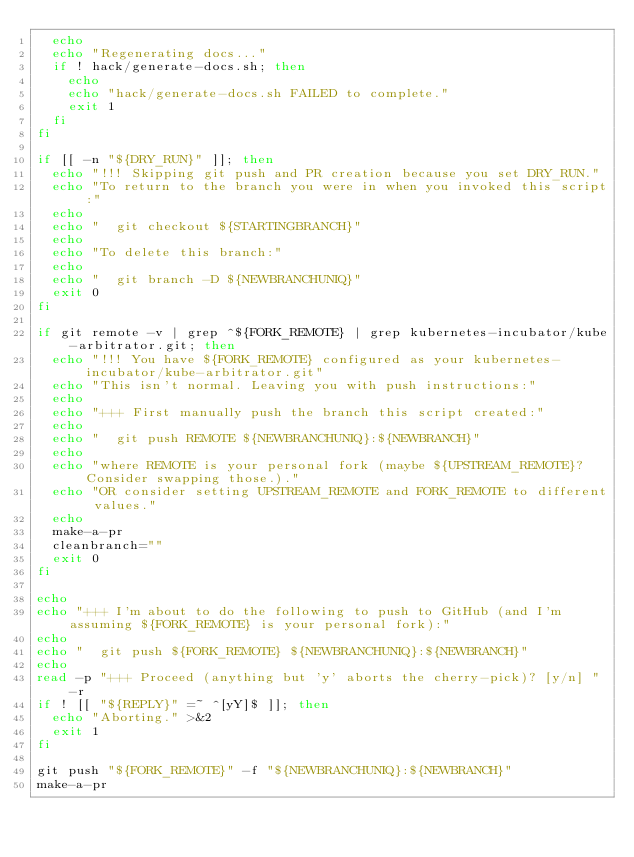Convert code to text. <code><loc_0><loc_0><loc_500><loc_500><_Bash_>  echo
  echo "Regenerating docs..."
  if ! hack/generate-docs.sh; then
    echo
    echo "hack/generate-docs.sh FAILED to complete."
    exit 1
  fi
fi

if [[ -n "${DRY_RUN}" ]]; then
  echo "!!! Skipping git push and PR creation because you set DRY_RUN."
  echo "To return to the branch you were in when you invoked this script:"
  echo
  echo "  git checkout ${STARTINGBRANCH}"
  echo
  echo "To delete this branch:"
  echo
  echo "  git branch -D ${NEWBRANCHUNIQ}"
  exit 0
fi

if git remote -v | grep ^${FORK_REMOTE} | grep kubernetes-incubator/kube-arbitrator.git; then
  echo "!!! You have ${FORK_REMOTE} configured as your kubernetes-incubator/kube-arbitrator.git"
  echo "This isn't normal. Leaving you with push instructions:"
  echo
  echo "+++ First manually push the branch this script created:"
  echo
  echo "  git push REMOTE ${NEWBRANCHUNIQ}:${NEWBRANCH}"
  echo
  echo "where REMOTE is your personal fork (maybe ${UPSTREAM_REMOTE}? Consider swapping those.)."
  echo "OR consider setting UPSTREAM_REMOTE and FORK_REMOTE to different values."
  echo
  make-a-pr
  cleanbranch=""
  exit 0
fi

echo
echo "+++ I'm about to do the following to push to GitHub (and I'm assuming ${FORK_REMOTE} is your personal fork):"
echo
echo "  git push ${FORK_REMOTE} ${NEWBRANCHUNIQ}:${NEWBRANCH}"
echo
read -p "+++ Proceed (anything but 'y' aborts the cherry-pick)? [y/n] " -r
if ! [[ "${REPLY}" =~ ^[yY]$ ]]; then
  echo "Aborting." >&2
  exit 1
fi

git push "${FORK_REMOTE}" -f "${NEWBRANCHUNIQ}:${NEWBRANCH}"
make-a-pr
</code> 